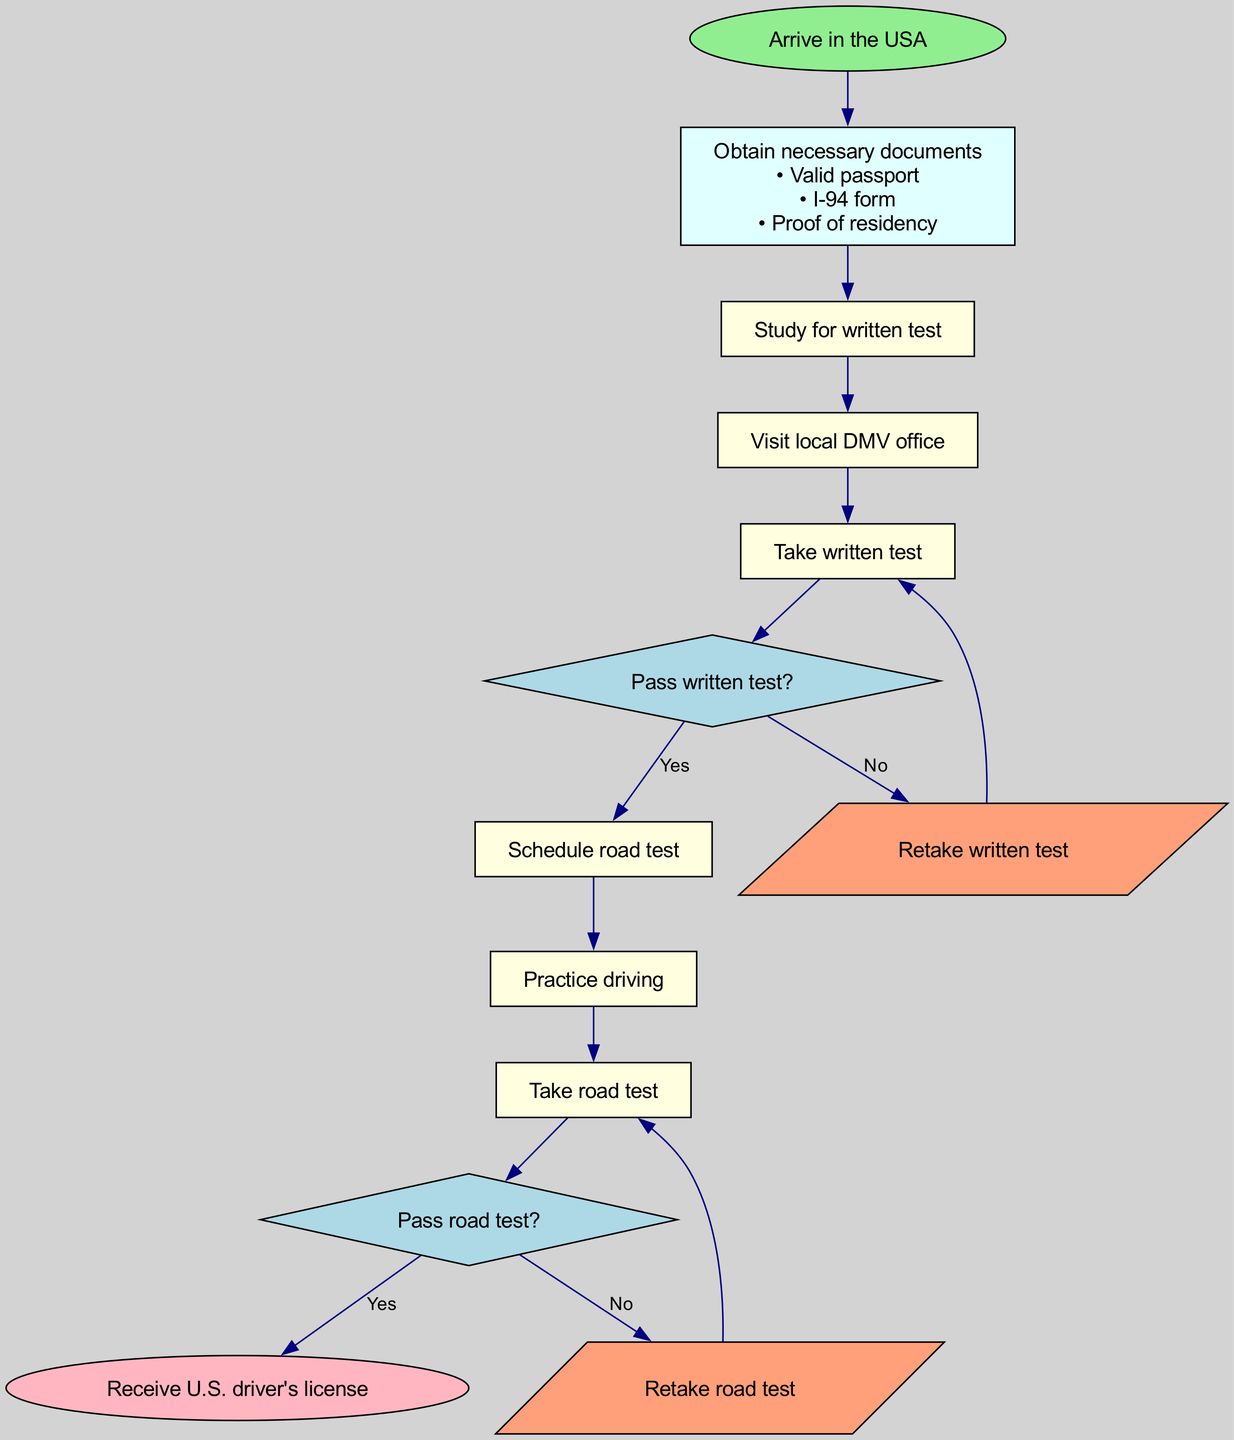What is the first step after arriving in the USA? After arriving in the USA, the next step according to the diagram is to obtain necessary documents. This is shown as the first action directed from the start node.
Answer: Obtain necessary documents How many decision nodes are present in the diagram? The diagram contains two decision nodes: one after taking the written test and another after taking the road test. This can be counted by identifying each diamond-shaped node in the flowchart.
Answer: 2 Which document is required to prove residency? The diagram lists proof of residency as one of the necessary documents to obtain a driver's license. The element clearly states this in the details section under "Obtain necessary documents."
Answer: Proof of residency What action follows after passing the written test? Upon passing the written test, the flow directs to schedule the road test. This follows the decision node labeled "Pass written test?" which leads to the step for scheduling the road test if the answer is yes.
Answer: Schedule road test What happens if a person fails the road test? If a person does not pass the road test, the flowchart leads back to retaking the road test as indicated by the decision node "Pass road test?". The "No" connection shows this retry process explicitly.
Answer: Retake road test Which step involves practicing driving? Practicing driving is directly listed as step 6 in the flowchart, which comes after scheduling the road test and before taking the road test.
Answer: Practice driving What shape represents the start and end nodes in the diagram? The start and end nodes in the diagram are represented as ovals, which is a common visual cue in flowcharts to denote the beginning and termination points.
Answer: Oval How many steps are there between arrival in the USA and receiving a driver's license? There are six steps including all actions from obtaining documents to receiving the license. The steps are: Obtain documents, Study for written test, Visit local DMV office, Take written test, Schedule road test, and Practice driving, ending with taking the road test.
Answer: 6 